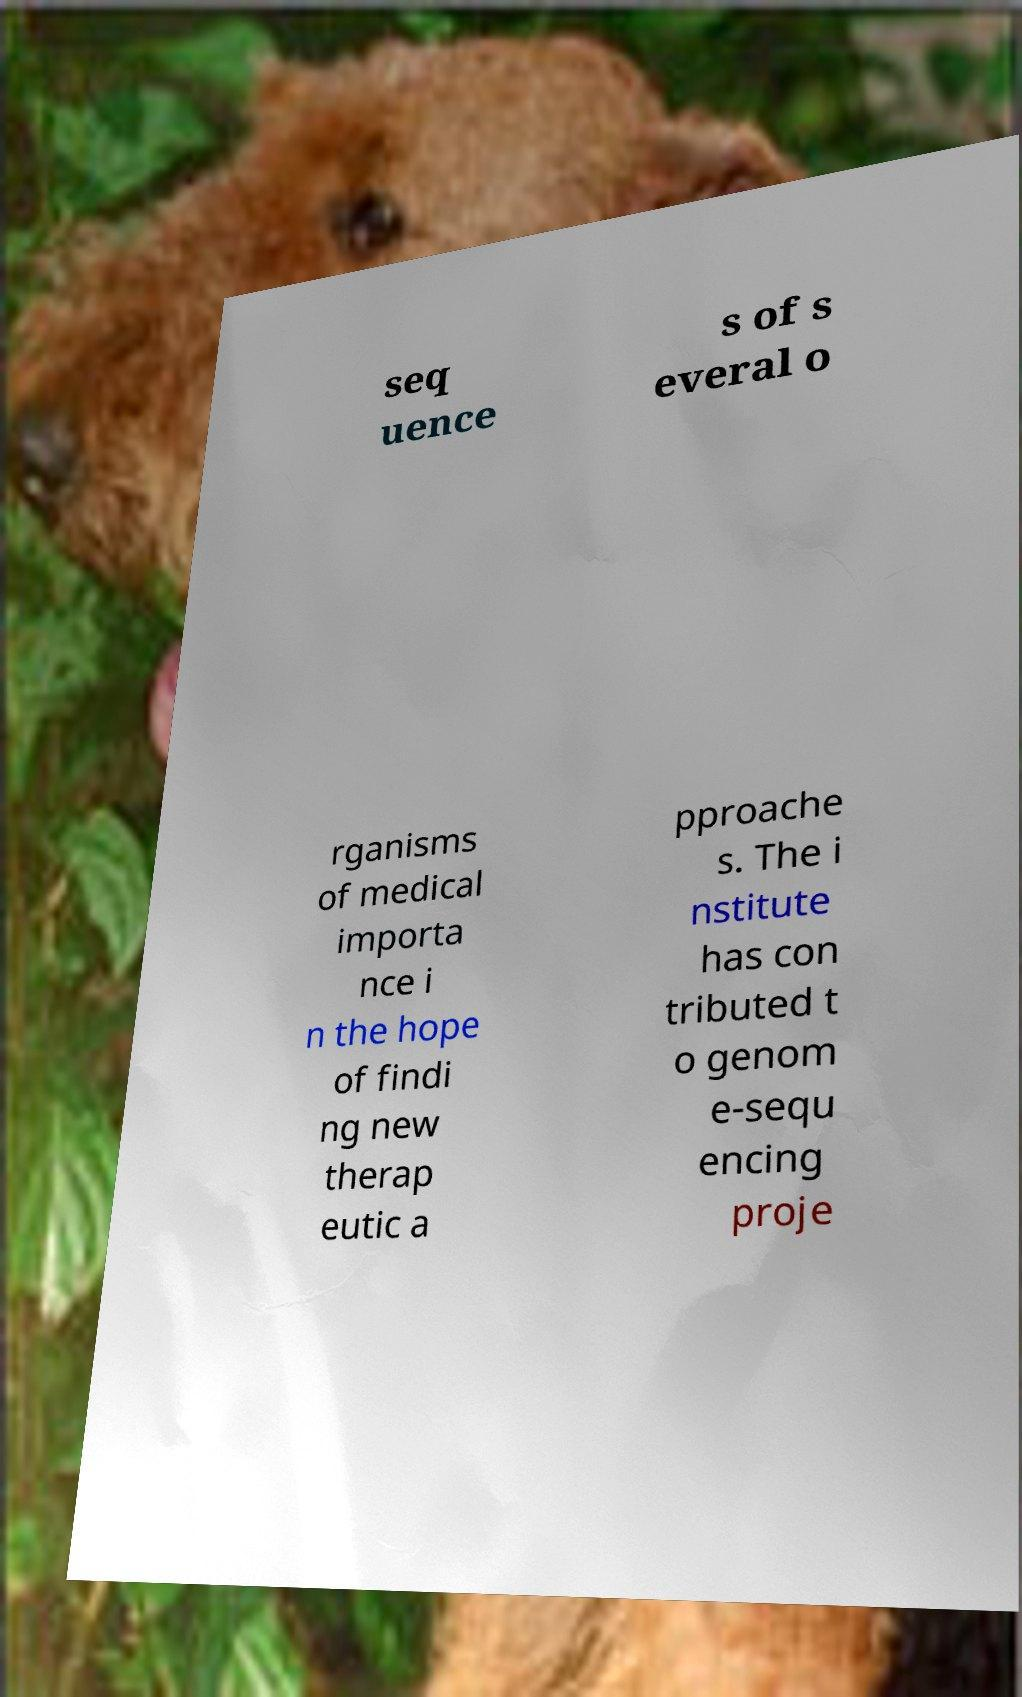What messages or text are displayed in this image? I need them in a readable, typed format. seq uence s of s everal o rganisms of medical importa nce i n the hope of findi ng new therap eutic a pproache s. The i nstitute has con tributed t o genom e-sequ encing proje 